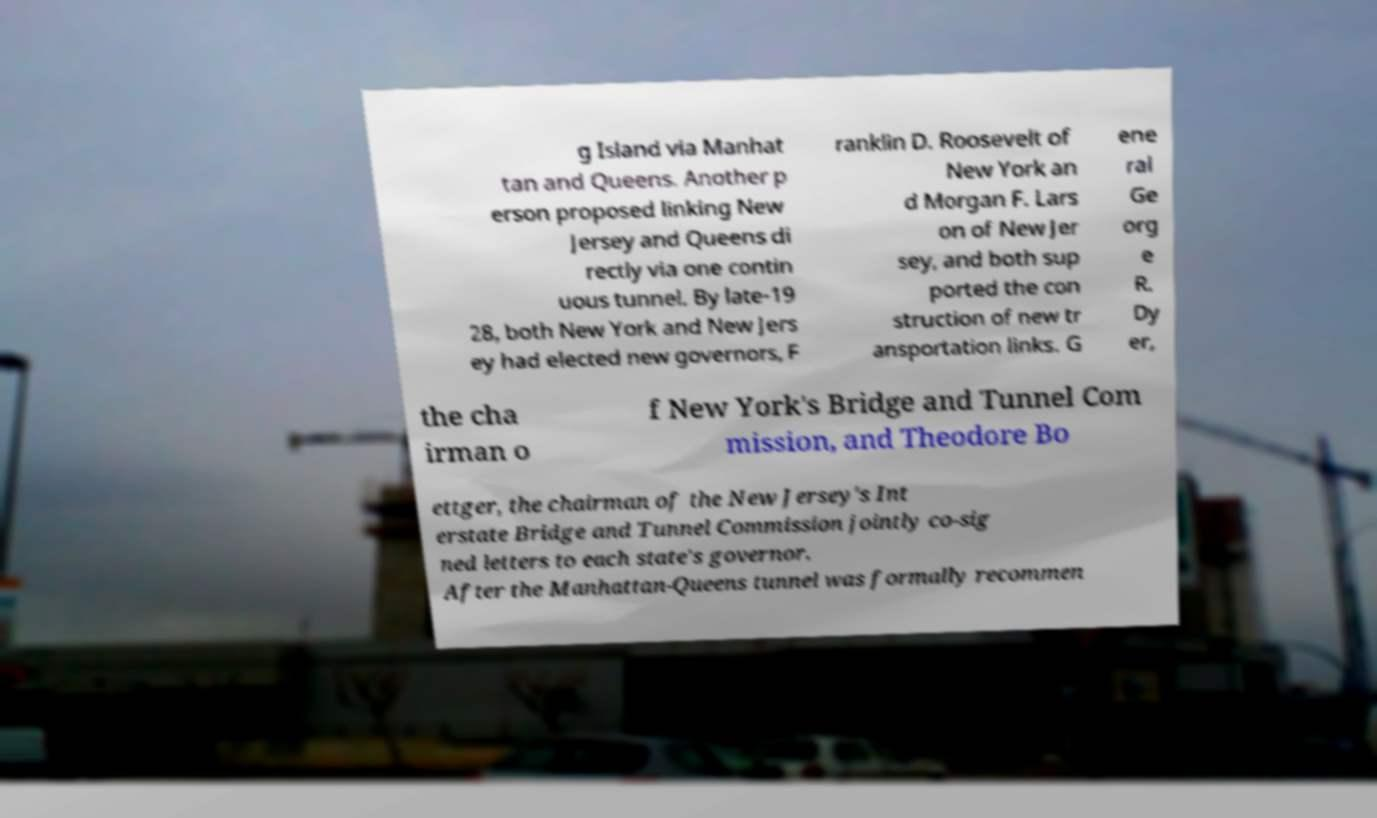Could you assist in decoding the text presented in this image and type it out clearly? g Island via Manhat tan and Queens. Another p erson proposed linking New Jersey and Queens di rectly via one contin uous tunnel. By late-19 28, both New York and New Jers ey had elected new governors, F ranklin D. Roosevelt of New York an d Morgan F. Lars on of New Jer sey, and both sup ported the con struction of new tr ansportation links. G ene ral Ge org e R. Dy er, the cha irman o f New York's Bridge and Tunnel Com mission, and Theodore Bo ettger, the chairman of the New Jersey's Int erstate Bridge and Tunnel Commission jointly co-sig ned letters to each state's governor. After the Manhattan-Queens tunnel was formally recommen 